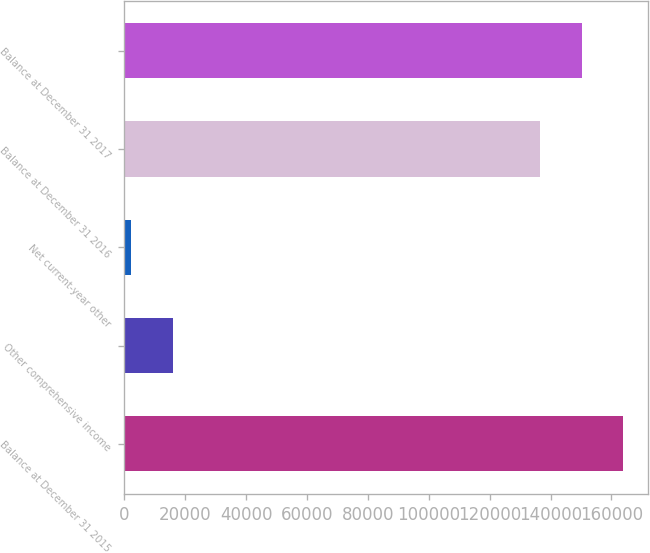<chart> <loc_0><loc_0><loc_500><loc_500><bar_chart><fcel>Balance at December 31 2015<fcel>Other comprehensive income<fcel>Net current-year other<fcel>Balance at December 31 2016<fcel>Balance at December 31 2017<nl><fcel>163931<fcel>15879.5<fcel>2212<fcel>136596<fcel>150264<nl></chart> 